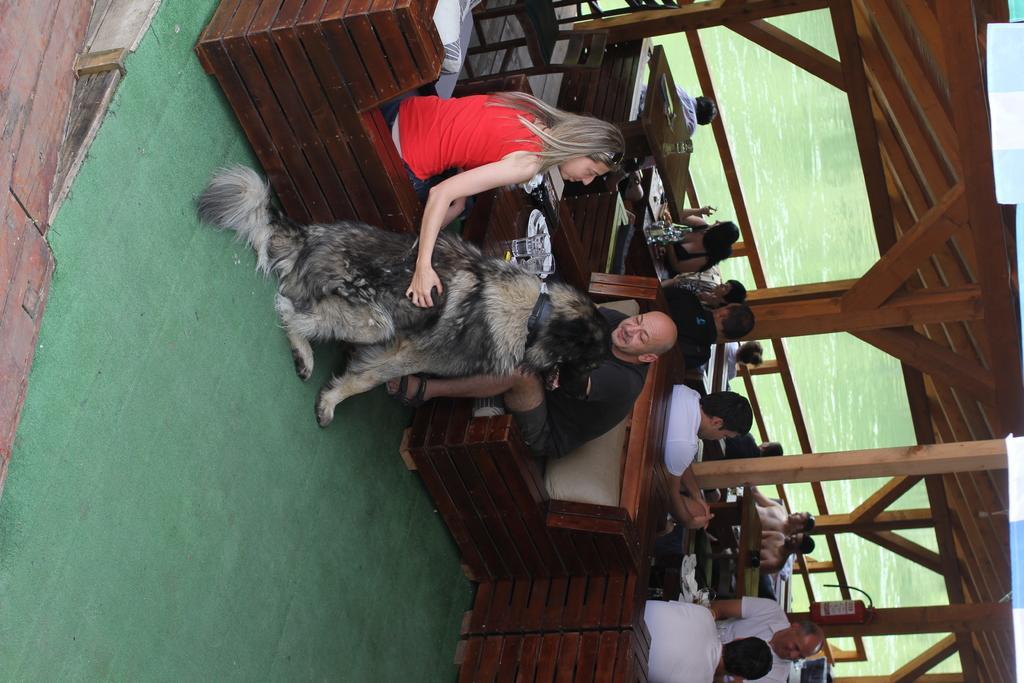Describe this image in one or two sentences. In this picture, we can see a few people sitting, and we can see the ground, a dog, tables, roof, and we can see water. 